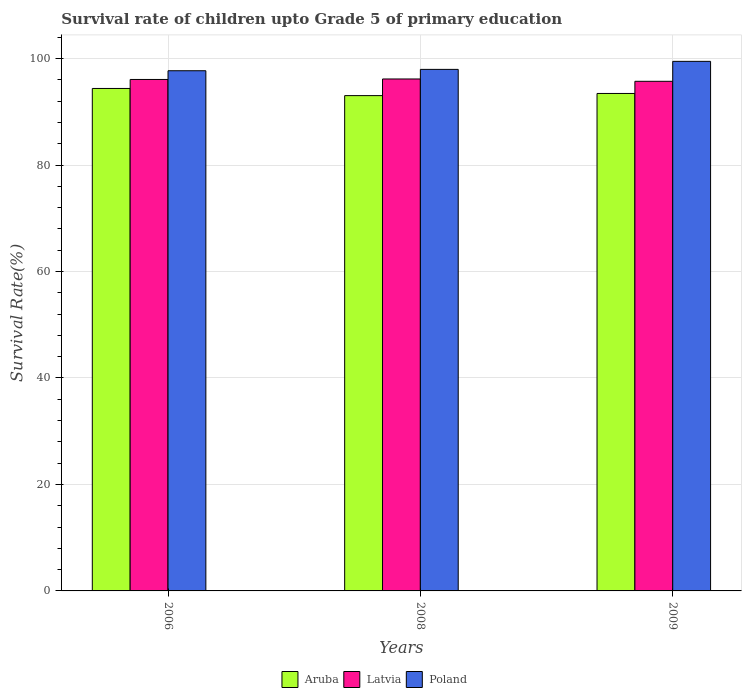Are the number of bars per tick equal to the number of legend labels?
Provide a succinct answer. Yes. What is the label of the 3rd group of bars from the left?
Make the answer very short. 2009. What is the survival rate of children in Aruba in 2008?
Provide a succinct answer. 93.04. Across all years, what is the maximum survival rate of children in Poland?
Provide a short and direct response. 99.48. Across all years, what is the minimum survival rate of children in Aruba?
Provide a succinct answer. 93.04. In which year was the survival rate of children in Poland maximum?
Your response must be concise. 2009. In which year was the survival rate of children in Poland minimum?
Offer a very short reply. 2006. What is the total survival rate of children in Aruba in the graph?
Your answer should be very brief. 280.87. What is the difference between the survival rate of children in Poland in 2006 and that in 2008?
Your response must be concise. -0.25. What is the difference between the survival rate of children in Poland in 2009 and the survival rate of children in Aruba in 2006?
Your answer should be compact. 5.09. What is the average survival rate of children in Poland per year?
Your answer should be compact. 98.39. In the year 2008, what is the difference between the survival rate of children in Poland and survival rate of children in Latvia?
Keep it short and to the point. 1.8. In how many years, is the survival rate of children in Poland greater than 44 %?
Provide a succinct answer. 3. What is the ratio of the survival rate of children in Aruba in 2006 to that in 2009?
Your answer should be compact. 1.01. Is the survival rate of children in Aruba in 2008 less than that in 2009?
Ensure brevity in your answer.  Yes. Is the difference between the survival rate of children in Poland in 2006 and 2008 greater than the difference between the survival rate of children in Latvia in 2006 and 2008?
Your answer should be very brief. No. What is the difference between the highest and the second highest survival rate of children in Poland?
Your response must be concise. 1.51. What is the difference between the highest and the lowest survival rate of children in Aruba?
Provide a short and direct response. 1.34. What does the 2nd bar from the left in 2008 represents?
Your answer should be very brief. Latvia. What does the 1st bar from the right in 2008 represents?
Offer a terse response. Poland. Is it the case that in every year, the sum of the survival rate of children in Aruba and survival rate of children in Poland is greater than the survival rate of children in Latvia?
Make the answer very short. Yes. How many bars are there?
Provide a short and direct response. 9. Are the values on the major ticks of Y-axis written in scientific E-notation?
Provide a short and direct response. No. Does the graph contain any zero values?
Offer a terse response. No. What is the title of the graph?
Your answer should be compact. Survival rate of children upto Grade 5 of primary education. What is the label or title of the X-axis?
Your response must be concise. Years. What is the label or title of the Y-axis?
Keep it short and to the point. Survival Rate(%). What is the Survival Rate(%) of Aruba in 2006?
Offer a terse response. 94.39. What is the Survival Rate(%) in Latvia in 2006?
Offer a very short reply. 96.08. What is the Survival Rate(%) in Poland in 2006?
Provide a succinct answer. 97.71. What is the Survival Rate(%) in Aruba in 2008?
Make the answer very short. 93.04. What is the Survival Rate(%) of Latvia in 2008?
Keep it short and to the point. 96.17. What is the Survival Rate(%) in Poland in 2008?
Offer a very short reply. 97.97. What is the Survival Rate(%) in Aruba in 2009?
Provide a succinct answer. 93.44. What is the Survival Rate(%) of Latvia in 2009?
Offer a terse response. 95.73. What is the Survival Rate(%) in Poland in 2009?
Your answer should be very brief. 99.48. Across all years, what is the maximum Survival Rate(%) of Aruba?
Provide a short and direct response. 94.39. Across all years, what is the maximum Survival Rate(%) in Latvia?
Your answer should be very brief. 96.17. Across all years, what is the maximum Survival Rate(%) in Poland?
Your response must be concise. 99.48. Across all years, what is the minimum Survival Rate(%) of Aruba?
Keep it short and to the point. 93.04. Across all years, what is the minimum Survival Rate(%) of Latvia?
Your answer should be very brief. 95.73. Across all years, what is the minimum Survival Rate(%) of Poland?
Make the answer very short. 97.71. What is the total Survival Rate(%) of Aruba in the graph?
Offer a very short reply. 280.87. What is the total Survival Rate(%) in Latvia in the graph?
Your answer should be compact. 287.97. What is the total Survival Rate(%) of Poland in the graph?
Offer a very short reply. 295.16. What is the difference between the Survival Rate(%) in Aruba in 2006 and that in 2008?
Offer a very short reply. 1.34. What is the difference between the Survival Rate(%) of Latvia in 2006 and that in 2008?
Your answer should be very brief. -0.09. What is the difference between the Survival Rate(%) of Poland in 2006 and that in 2008?
Your answer should be very brief. -0.25. What is the difference between the Survival Rate(%) in Aruba in 2006 and that in 2009?
Your response must be concise. 0.94. What is the difference between the Survival Rate(%) in Latvia in 2006 and that in 2009?
Keep it short and to the point. 0.35. What is the difference between the Survival Rate(%) in Poland in 2006 and that in 2009?
Keep it short and to the point. -1.76. What is the difference between the Survival Rate(%) of Aruba in 2008 and that in 2009?
Provide a succinct answer. -0.4. What is the difference between the Survival Rate(%) in Latvia in 2008 and that in 2009?
Provide a succinct answer. 0.44. What is the difference between the Survival Rate(%) in Poland in 2008 and that in 2009?
Keep it short and to the point. -1.51. What is the difference between the Survival Rate(%) in Aruba in 2006 and the Survival Rate(%) in Latvia in 2008?
Your answer should be very brief. -1.78. What is the difference between the Survival Rate(%) in Aruba in 2006 and the Survival Rate(%) in Poland in 2008?
Provide a short and direct response. -3.58. What is the difference between the Survival Rate(%) of Latvia in 2006 and the Survival Rate(%) of Poland in 2008?
Give a very brief answer. -1.89. What is the difference between the Survival Rate(%) in Aruba in 2006 and the Survival Rate(%) in Latvia in 2009?
Provide a short and direct response. -1.34. What is the difference between the Survival Rate(%) of Aruba in 2006 and the Survival Rate(%) of Poland in 2009?
Your response must be concise. -5.09. What is the difference between the Survival Rate(%) in Latvia in 2006 and the Survival Rate(%) in Poland in 2009?
Ensure brevity in your answer.  -3.4. What is the difference between the Survival Rate(%) of Aruba in 2008 and the Survival Rate(%) of Latvia in 2009?
Make the answer very short. -2.69. What is the difference between the Survival Rate(%) in Aruba in 2008 and the Survival Rate(%) in Poland in 2009?
Your response must be concise. -6.44. What is the difference between the Survival Rate(%) of Latvia in 2008 and the Survival Rate(%) of Poland in 2009?
Offer a terse response. -3.31. What is the average Survival Rate(%) in Aruba per year?
Provide a succinct answer. 93.62. What is the average Survival Rate(%) of Latvia per year?
Your answer should be compact. 95.99. What is the average Survival Rate(%) of Poland per year?
Offer a very short reply. 98.39. In the year 2006, what is the difference between the Survival Rate(%) in Aruba and Survival Rate(%) in Latvia?
Make the answer very short. -1.69. In the year 2006, what is the difference between the Survival Rate(%) of Aruba and Survival Rate(%) of Poland?
Ensure brevity in your answer.  -3.33. In the year 2006, what is the difference between the Survival Rate(%) in Latvia and Survival Rate(%) in Poland?
Offer a terse response. -1.64. In the year 2008, what is the difference between the Survival Rate(%) in Aruba and Survival Rate(%) in Latvia?
Your response must be concise. -3.12. In the year 2008, what is the difference between the Survival Rate(%) in Aruba and Survival Rate(%) in Poland?
Your answer should be compact. -4.93. In the year 2008, what is the difference between the Survival Rate(%) in Latvia and Survival Rate(%) in Poland?
Offer a terse response. -1.8. In the year 2009, what is the difference between the Survival Rate(%) of Aruba and Survival Rate(%) of Latvia?
Provide a succinct answer. -2.28. In the year 2009, what is the difference between the Survival Rate(%) in Aruba and Survival Rate(%) in Poland?
Ensure brevity in your answer.  -6.03. In the year 2009, what is the difference between the Survival Rate(%) of Latvia and Survival Rate(%) of Poland?
Your answer should be very brief. -3.75. What is the ratio of the Survival Rate(%) in Aruba in 2006 to that in 2008?
Provide a succinct answer. 1.01. What is the ratio of the Survival Rate(%) of Poland in 2006 to that in 2008?
Offer a terse response. 1. What is the ratio of the Survival Rate(%) of Aruba in 2006 to that in 2009?
Keep it short and to the point. 1.01. What is the ratio of the Survival Rate(%) of Poland in 2006 to that in 2009?
Make the answer very short. 0.98. What is the ratio of the Survival Rate(%) in Aruba in 2008 to that in 2009?
Ensure brevity in your answer.  1. What is the difference between the highest and the second highest Survival Rate(%) in Aruba?
Make the answer very short. 0.94. What is the difference between the highest and the second highest Survival Rate(%) of Latvia?
Provide a succinct answer. 0.09. What is the difference between the highest and the second highest Survival Rate(%) of Poland?
Provide a succinct answer. 1.51. What is the difference between the highest and the lowest Survival Rate(%) in Aruba?
Offer a very short reply. 1.34. What is the difference between the highest and the lowest Survival Rate(%) in Latvia?
Ensure brevity in your answer.  0.44. What is the difference between the highest and the lowest Survival Rate(%) of Poland?
Give a very brief answer. 1.76. 